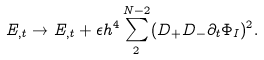Convert formula to latex. <formula><loc_0><loc_0><loc_500><loc_500>E _ { , t } \rightarrow E _ { , t } + \epsilon h ^ { 4 } \sum _ { 2 } ^ { N - 2 } ( D _ { + } D _ { - } \partial _ { t } \Phi _ { I } ) ^ { 2 } .</formula> 